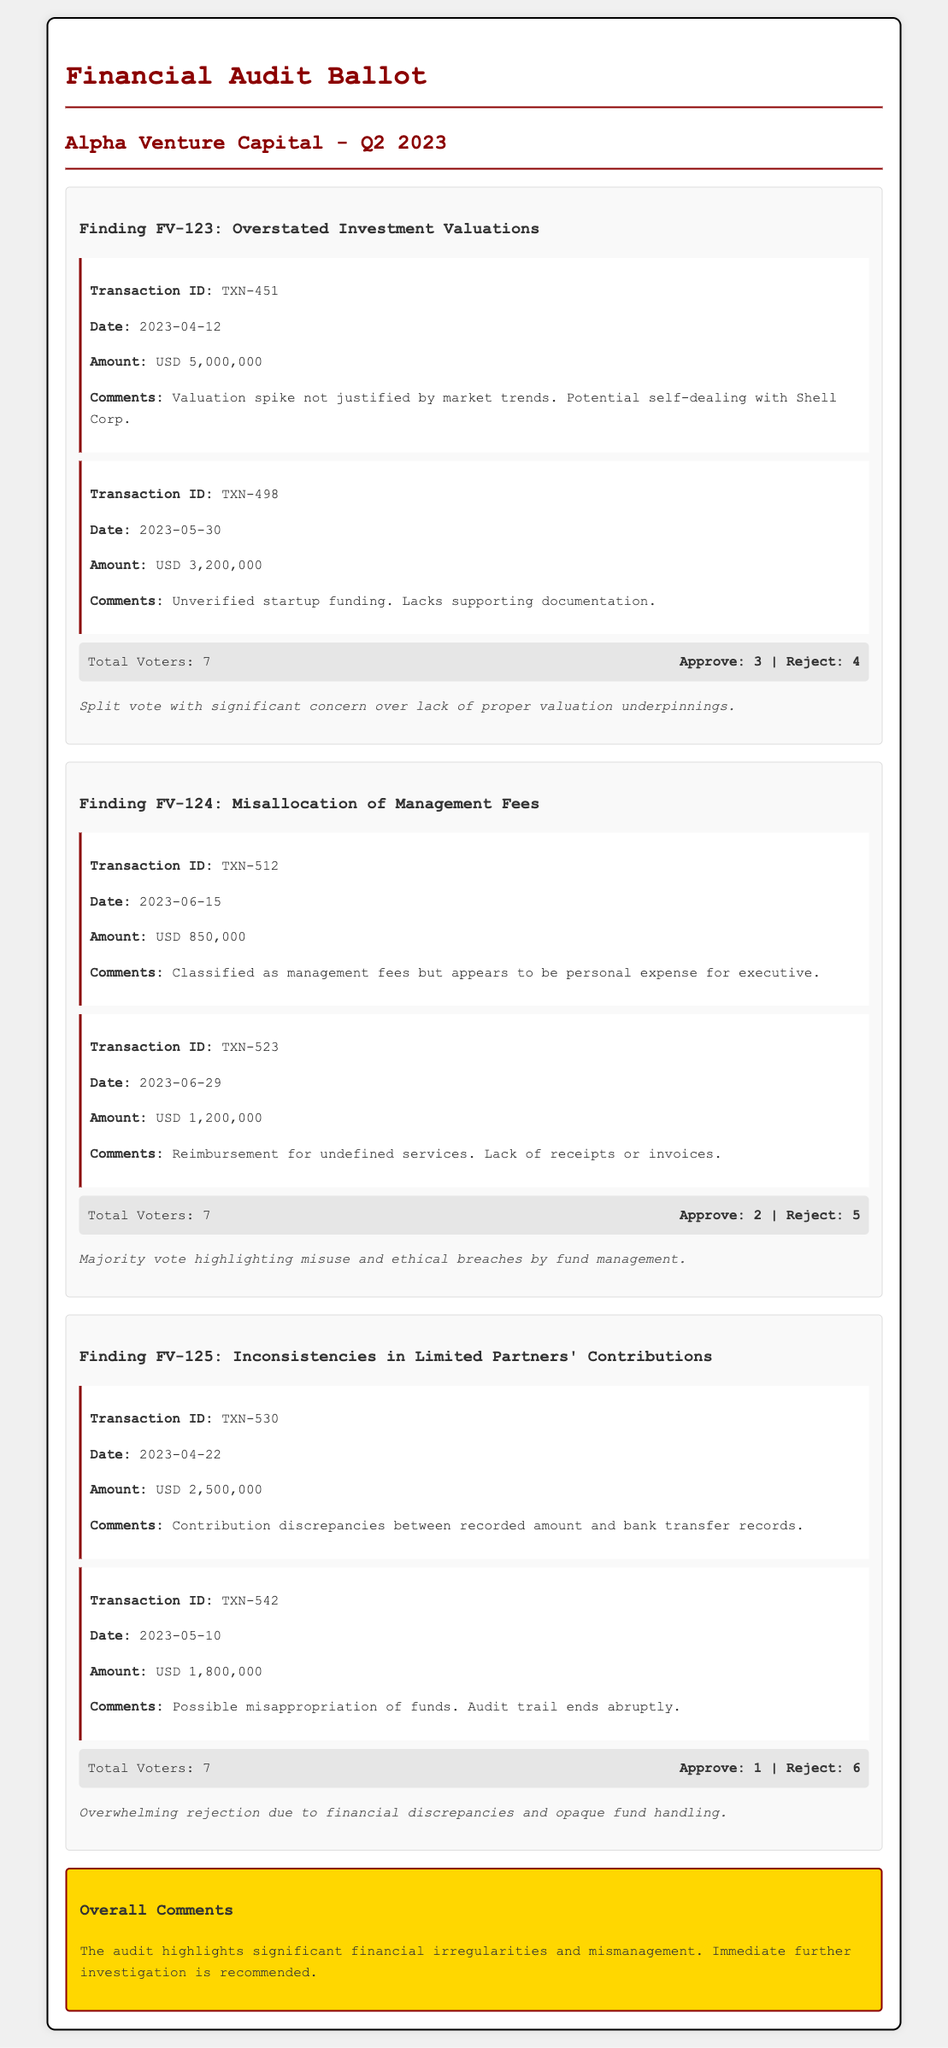What is the total amount related to Finding FV-123? The total amount related to Finding FV-123 is the sum of the two transactions listed under it, which are USD 5,000,000 and USD 3,200,000.
Answer: USD 8,200,000 How many total voters were there for Finding FV-124? The total number of voters for Finding FV-124 is stated at the end of the voting section under that finding.
Answer: 7 What was the date of the transaction with ID TXN-512? The date for transaction ID TXN-512 is mentioned in the details of that specific transaction.
Answer: 2023-06-15 Which finding received the most rejections? The finding with the highest number of rejections is identified through the voting results listed under each finding.
Answer: FV-125 What was the amount of the transaction on 2023-04-22? This amount is specified in the transaction details for the corresponding date under Finding FV-125.
Answer: USD 2,500,000 What was the total approval count for Finding FV-124? The total approval count is given in the voting results for Finding FV-124.
Answer: 2 What significant issue is highlighted in the overall comments? The overall comments summarize the general issues found throughout the audit without needing to reference a specific finding.
Answer: Significant financial irregularities How many transactions are listed under Finding FV-123? The number of transactions can be counted directly from the finding section where they are detailed.
Answer: 2 What was the amount for transaction ID TXN-523? The amount is explicitly mentioned in the transaction details for that specific ID under Finding FV-124.
Answer: USD 1,200,000 